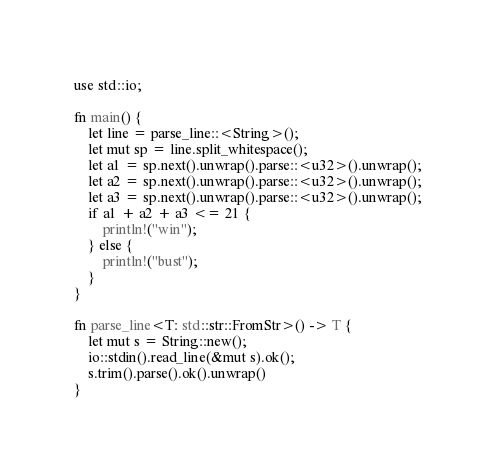Convert code to text. <code><loc_0><loc_0><loc_500><loc_500><_Rust_>use std::io;

fn main() {
    let line = parse_line::<String>();
    let mut sp = line.split_whitespace();
    let a1 = sp.next().unwrap().parse::<u32>().unwrap();
    let a2 = sp.next().unwrap().parse::<u32>().unwrap();
    let a3 = sp.next().unwrap().parse::<u32>().unwrap();
    if a1 + a2 + a3 <= 21 {
        println!("win");
    } else {
        println!("bust");
    }
}

fn parse_line<T: std::str::FromStr>() -> T {
    let mut s = String::new();
    io::stdin().read_line(&mut s).ok();
    s.trim().parse().ok().unwrap()
}
</code> 